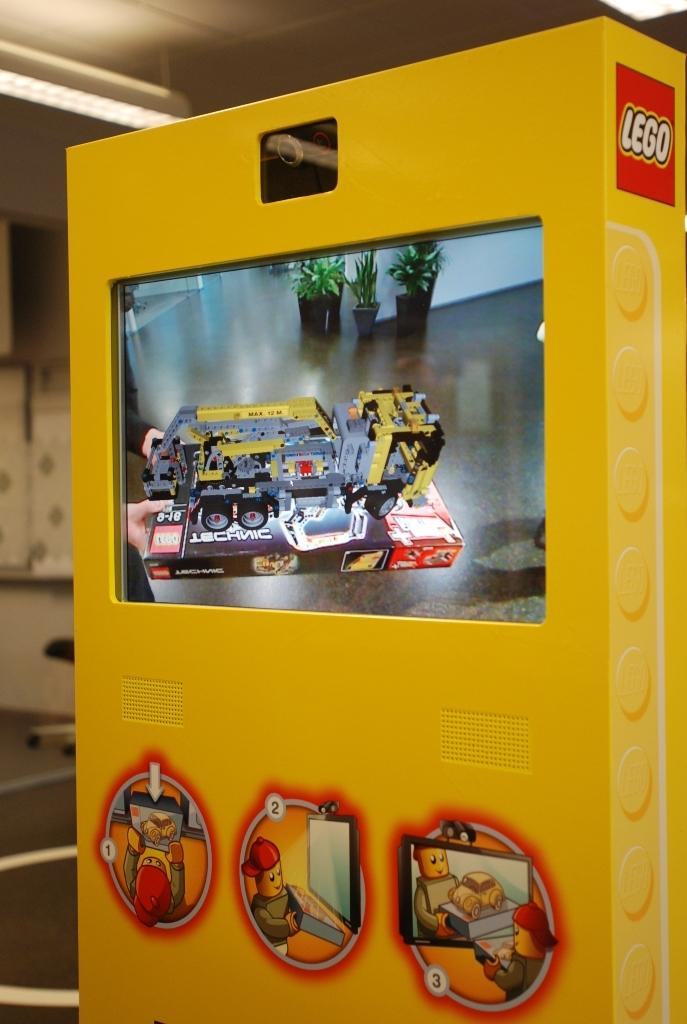What is the main object in the foreground of the image? There is a yellow machine in the foreground of the image. What feature is associated with the yellow machine? There is a screen associated with the yellow machine. What can be seen in the background of the image? The background of the image includes the ceiling, lights, a chair, the floor, and a wall. What type of mountain is visible in the background of the image? There is no mountain visible in the background of the image. How many wheels are present on the yellow machine in the image? The image does not show the number of wheels on the yellow machine, as it only shows the machine's front side. 